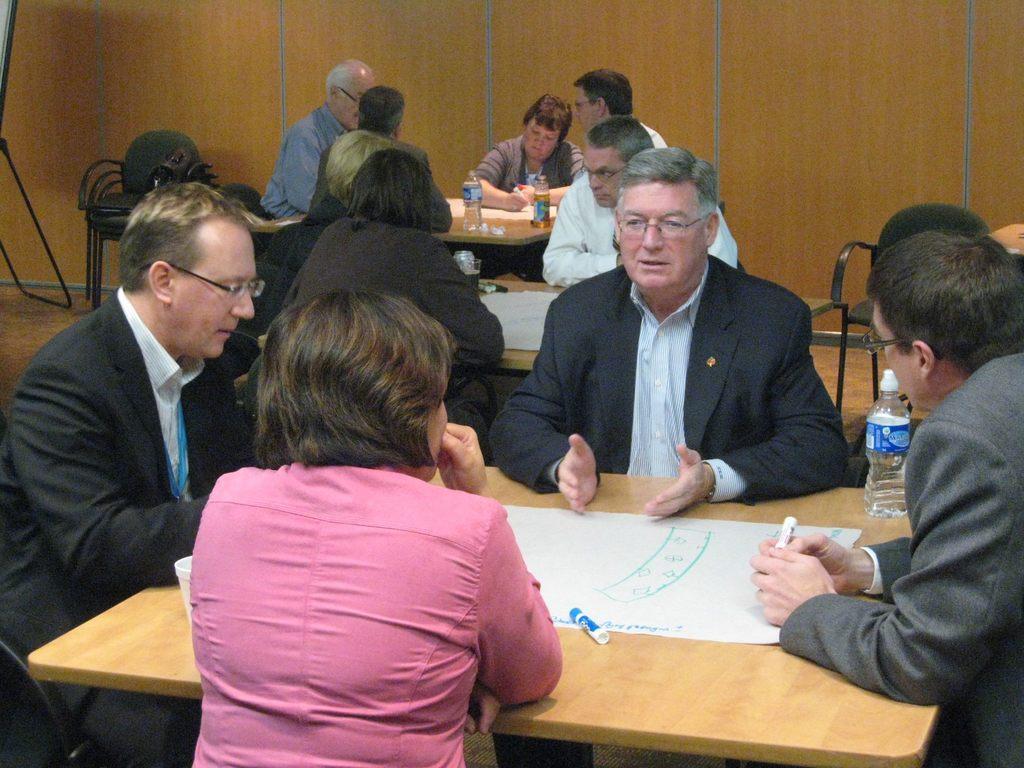Please provide a concise description of this image. In this image there are four people who are sitting around the table and discussing between them. On the table there is paper,marker and the bottle. At the background their are another group of people who are sitting around the table and talking with each other. At the left side there is chair and the stand. At the back side there is a wall. 